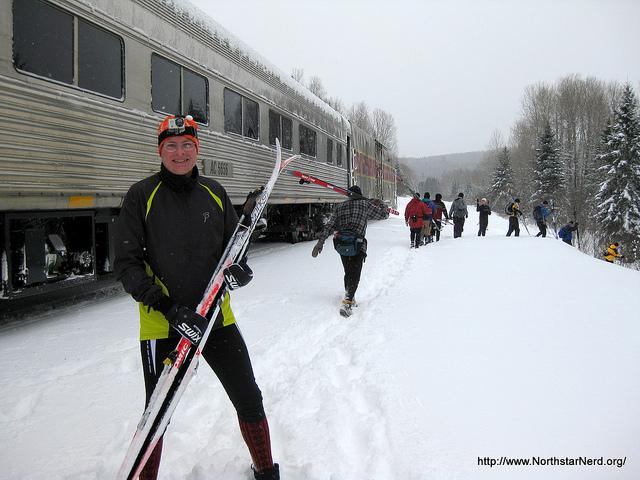How did these skiers get to this location? train 